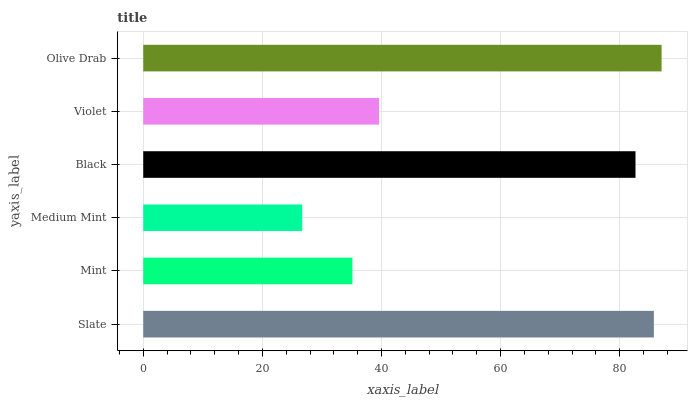Is Medium Mint the minimum?
Answer yes or no. Yes. Is Olive Drab the maximum?
Answer yes or no. Yes. Is Mint the minimum?
Answer yes or no. No. Is Mint the maximum?
Answer yes or no. No. Is Slate greater than Mint?
Answer yes or no. Yes. Is Mint less than Slate?
Answer yes or no. Yes. Is Mint greater than Slate?
Answer yes or no. No. Is Slate less than Mint?
Answer yes or no. No. Is Black the high median?
Answer yes or no. Yes. Is Violet the low median?
Answer yes or no. Yes. Is Mint the high median?
Answer yes or no. No. Is Mint the low median?
Answer yes or no. No. 